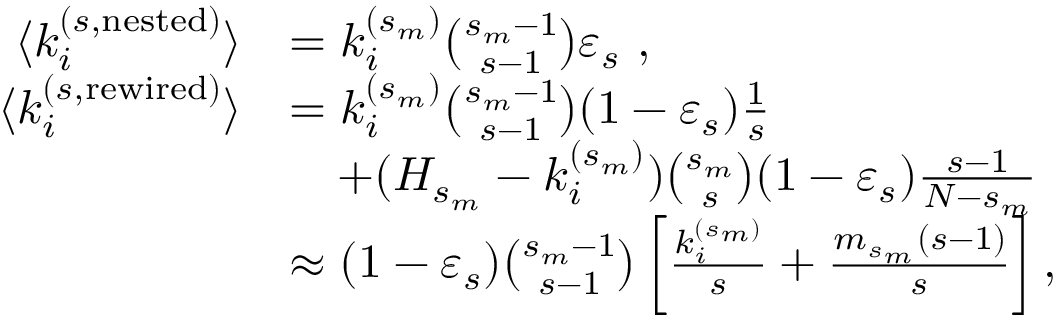Convert formula to latex. <formula><loc_0><loc_0><loc_500><loc_500>\begin{array} { r l } { \langle k _ { i } ^ { ( s , n e s t e d ) } \rangle } & { = k _ { i } ^ { ( s _ { m } ) } { \binom { s _ { m } - 1 } { s - 1 } } \varepsilon _ { s } , } \\ { \langle k _ { i } ^ { ( s , r e w i r e d ) } \rangle } & { = k _ { i } ^ { ( s _ { m } ) } { \binom { s _ { m } - 1 } { s - 1 } } ( 1 - \varepsilon _ { s } ) \frac { 1 } { s } } \\ & { \quad + ( H _ { s _ { m } } - k _ { i } ^ { ( s _ { m } ) } ) { \binom { s _ { m } } { s } } ( 1 - \varepsilon _ { s } ) \frac { s - 1 } { N - s _ { m } } } \\ & { \approx ( 1 - \varepsilon _ { s } ) { \binom { s _ { m } - 1 } { s - 1 } } \left [ \frac { k _ { i } ^ { ( s _ { m } ) } } { s } + \frac { m _ { s _ { m } } ( s - 1 ) } { s } \right ] , } \end{array}</formula> 